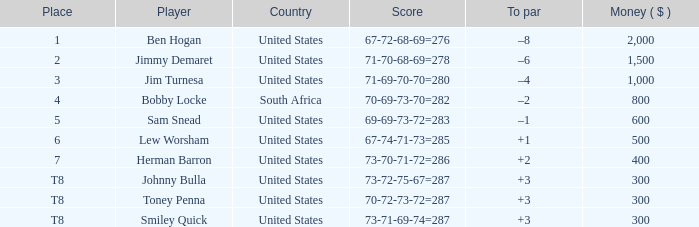What is the to par of the 4 spot player? –2. Could you parse the entire table? {'header': ['Place', 'Player', 'Country', 'Score', 'To par', 'Money ( $ )'], 'rows': [['1', 'Ben Hogan', 'United States', '67-72-68-69=276', '–8', '2,000'], ['2', 'Jimmy Demaret', 'United States', '71-70-68-69=278', '–6', '1,500'], ['3', 'Jim Turnesa', 'United States', '71-69-70-70=280', '–4', '1,000'], ['4', 'Bobby Locke', 'South Africa', '70-69-73-70=282', '–2', '800'], ['5', 'Sam Snead', 'United States', '69-69-73-72=283', '–1', '600'], ['6', 'Lew Worsham', 'United States', '67-74-71-73=285', '+1', '500'], ['7', 'Herman Barron', 'United States', '73-70-71-72=286', '+2', '400'], ['T8', 'Johnny Bulla', 'United States', '73-72-75-67=287', '+3', '300'], ['T8', 'Toney Penna', 'United States', '70-72-73-72=287', '+3', '300'], ['T8', 'Smiley Quick', 'United States', '73-71-69-74=287', '+3', '300']]} 